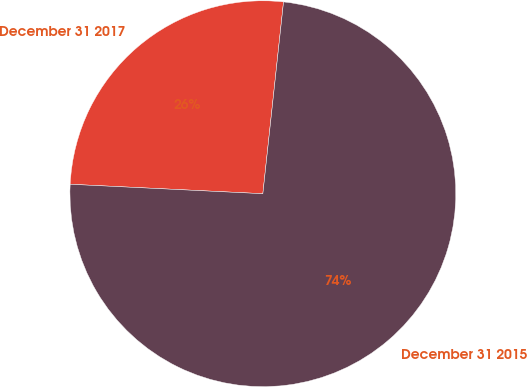Convert chart to OTSL. <chart><loc_0><loc_0><loc_500><loc_500><pie_chart><fcel>December 31 2017<fcel>December 31 2015<nl><fcel>25.93%<fcel>74.07%<nl></chart> 